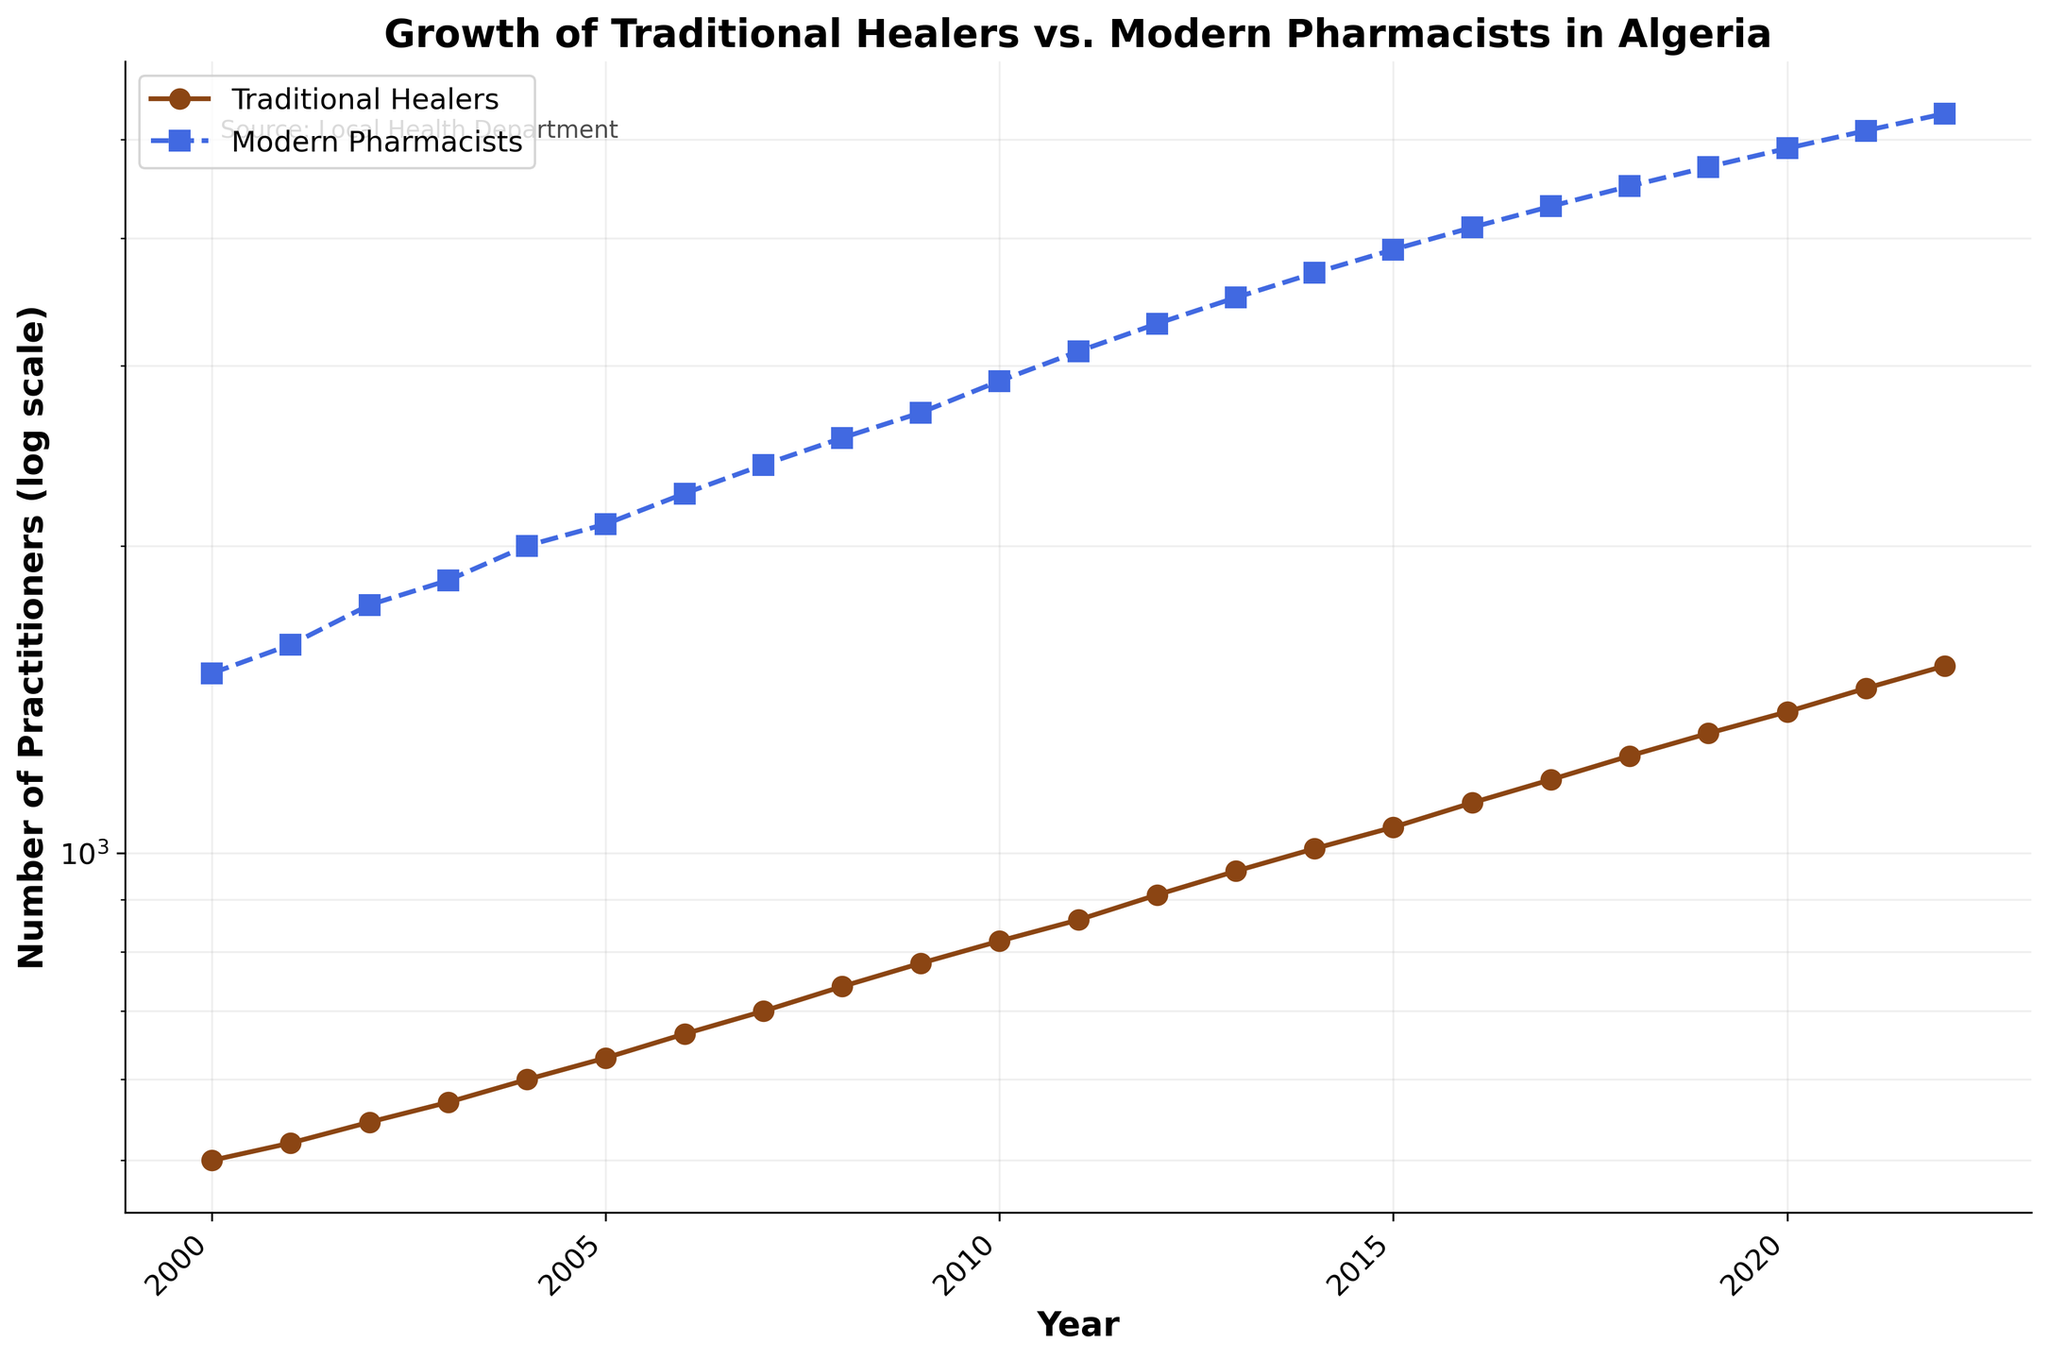What is the title of the figure? The title is located at the top of the figure and generally summarizes the displayed content. In this case, the title is "Growth of Traditional Healers vs. Modern Pharmacists in Algeria".
Answer: Growth of Traditional Healers vs. Modern Pharmacists in Algeria What does the y-axis represent? The y-axis label typically explains what is being measured on that axis. Here, it reads "Number of Practitioners (log scale)", indicating the number of practitioners is measured on a logarithmic scale.
Answer: Number of Practitioners (log scale) Which group had more practitioners in 2022? By looking at the legend and the data points for the year 2022, we can see that Modern Pharmacists have a higher data point compared to Traditional Healers.
Answer: Modern Pharmacists What is the trend of Traditional Healers from 2000 to 2022? Observing the curve of Traditional Healers from 2000 to 2022, the data points show a consistent upward trend, signifying continuous growth.
Answer: Upward trend Between which years did Modern Pharmacists see the largest growth on a logarithmic scale? To find the largest growth, we look for the steepest portion of the Modern Pharmacist line. This appears to be between 2010 and 2011, as there is a noticeable jump upwards.
Answer: 2010 to 2011 Compare the growth rates of Traditional Healers and Modern Pharmacists between 2018 and 2022. From the figure, both groups show an increase in the number of practitioners. However, the growth rate of Modern Pharmacists (in log scale) appears slightly steeper, indicating a faster growth compared to Traditional Healers.
Answer: Modern Pharmacists grew faster By how much did the number of Traditional Healers increase from 2000 to 2022? The figure shows the number of Traditional Healers in 2000 as approximately 500 and in 2022 as approximately 1525. The difference is 1525 - 500 = 1025.
Answer: 1025 Which year marks the first instance of Traditional Healers reaching over 1000 practitioners? By tracing the Traditional Healers' curve, they reach the 1000 mark in the year 2014.
Answer: 2014 